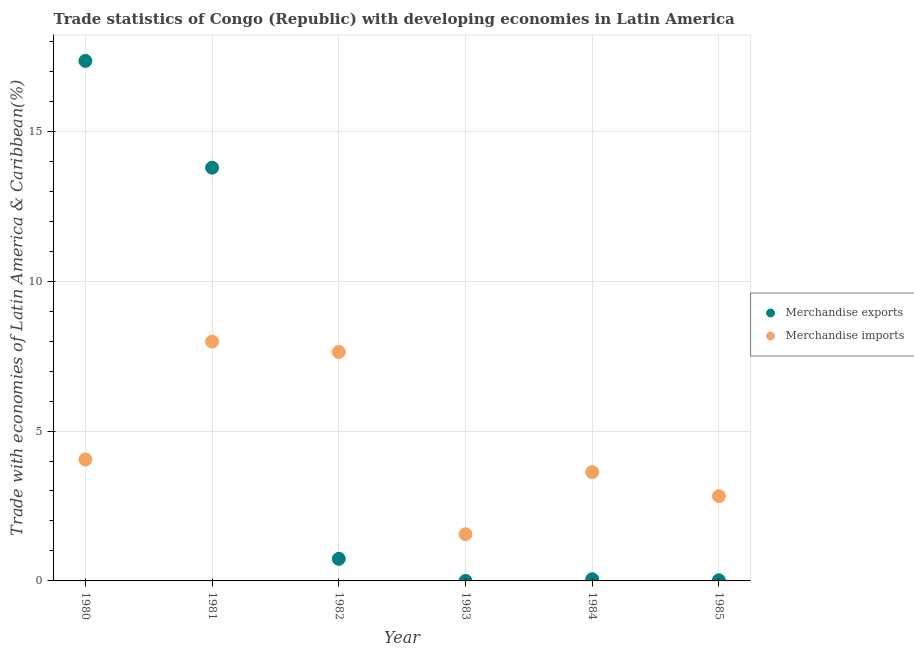What is the merchandise imports in 1980?
Provide a succinct answer. 4.05. Across all years, what is the maximum merchandise imports?
Your response must be concise. 7.98. Across all years, what is the minimum merchandise exports?
Give a very brief answer. 0. In which year was the merchandise imports maximum?
Keep it short and to the point. 1981. What is the total merchandise exports in the graph?
Offer a very short reply. 31.95. What is the difference between the merchandise imports in 1982 and that in 1984?
Provide a succinct answer. 4.01. What is the difference between the merchandise exports in 1981 and the merchandise imports in 1980?
Provide a short and direct response. 9.73. What is the average merchandise imports per year?
Make the answer very short. 4.61. In the year 1983, what is the difference between the merchandise imports and merchandise exports?
Provide a succinct answer. 1.56. In how many years, is the merchandise imports greater than 4 %?
Keep it short and to the point. 3. What is the ratio of the merchandise imports in 1981 to that in 1984?
Provide a short and direct response. 2.2. Is the merchandise exports in 1982 less than that in 1984?
Provide a succinct answer. No. Is the difference between the merchandise imports in 1982 and 1983 greater than the difference between the merchandise exports in 1982 and 1983?
Provide a short and direct response. Yes. What is the difference between the highest and the second highest merchandise exports?
Your answer should be compact. 3.56. What is the difference between the highest and the lowest merchandise imports?
Keep it short and to the point. 6.43. In how many years, is the merchandise imports greater than the average merchandise imports taken over all years?
Ensure brevity in your answer.  2. Is the sum of the merchandise imports in 1983 and 1985 greater than the maximum merchandise exports across all years?
Your answer should be compact. No. Does the merchandise exports monotonically increase over the years?
Provide a succinct answer. No. Is the merchandise imports strictly greater than the merchandise exports over the years?
Ensure brevity in your answer.  No. How many years are there in the graph?
Provide a short and direct response. 6. Does the graph contain any zero values?
Your response must be concise. No. Does the graph contain grids?
Give a very brief answer. Yes. How are the legend labels stacked?
Your answer should be very brief. Vertical. What is the title of the graph?
Your response must be concise. Trade statistics of Congo (Republic) with developing economies in Latin America. Does "Registered firms" appear as one of the legend labels in the graph?
Make the answer very short. No. What is the label or title of the X-axis?
Make the answer very short. Year. What is the label or title of the Y-axis?
Make the answer very short. Trade with economies of Latin America & Caribbean(%). What is the Trade with economies of Latin America & Caribbean(%) of Merchandise exports in 1980?
Provide a succinct answer. 17.35. What is the Trade with economies of Latin America & Caribbean(%) in Merchandise imports in 1980?
Your answer should be very brief. 4.05. What is the Trade with economies of Latin America & Caribbean(%) in Merchandise exports in 1981?
Your response must be concise. 13.78. What is the Trade with economies of Latin America & Caribbean(%) of Merchandise imports in 1981?
Offer a terse response. 7.98. What is the Trade with economies of Latin America & Caribbean(%) of Merchandise exports in 1982?
Ensure brevity in your answer.  0.74. What is the Trade with economies of Latin America & Caribbean(%) in Merchandise imports in 1982?
Keep it short and to the point. 7.64. What is the Trade with economies of Latin America & Caribbean(%) of Merchandise exports in 1983?
Your answer should be very brief. 0. What is the Trade with economies of Latin America & Caribbean(%) of Merchandise imports in 1983?
Offer a terse response. 1.56. What is the Trade with economies of Latin America & Caribbean(%) of Merchandise exports in 1984?
Ensure brevity in your answer.  0.06. What is the Trade with economies of Latin America & Caribbean(%) in Merchandise imports in 1984?
Keep it short and to the point. 3.63. What is the Trade with economies of Latin America & Caribbean(%) of Merchandise exports in 1985?
Your answer should be compact. 0.02. What is the Trade with economies of Latin America & Caribbean(%) in Merchandise imports in 1985?
Your answer should be compact. 2.83. Across all years, what is the maximum Trade with economies of Latin America & Caribbean(%) of Merchandise exports?
Ensure brevity in your answer.  17.35. Across all years, what is the maximum Trade with economies of Latin America & Caribbean(%) in Merchandise imports?
Offer a very short reply. 7.98. Across all years, what is the minimum Trade with economies of Latin America & Caribbean(%) in Merchandise exports?
Your response must be concise. 0. Across all years, what is the minimum Trade with economies of Latin America & Caribbean(%) of Merchandise imports?
Provide a short and direct response. 1.56. What is the total Trade with economies of Latin America & Caribbean(%) of Merchandise exports in the graph?
Your response must be concise. 31.95. What is the total Trade with economies of Latin America & Caribbean(%) in Merchandise imports in the graph?
Give a very brief answer. 27.69. What is the difference between the Trade with economies of Latin America & Caribbean(%) of Merchandise exports in 1980 and that in 1981?
Offer a very short reply. 3.56. What is the difference between the Trade with economies of Latin America & Caribbean(%) in Merchandise imports in 1980 and that in 1981?
Offer a very short reply. -3.93. What is the difference between the Trade with economies of Latin America & Caribbean(%) in Merchandise exports in 1980 and that in 1982?
Offer a terse response. 16.61. What is the difference between the Trade with economies of Latin America & Caribbean(%) in Merchandise imports in 1980 and that in 1982?
Make the answer very short. -3.58. What is the difference between the Trade with economies of Latin America & Caribbean(%) of Merchandise exports in 1980 and that in 1983?
Provide a short and direct response. 17.35. What is the difference between the Trade with economies of Latin America & Caribbean(%) of Merchandise imports in 1980 and that in 1983?
Your answer should be compact. 2.49. What is the difference between the Trade with economies of Latin America & Caribbean(%) in Merchandise exports in 1980 and that in 1984?
Ensure brevity in your answer.  17.29. What is the difference between the Trade with economies of Latin America & Caribbean(%) of Merchandise imports in 1980 and that in 1984?
Your answer should be compact. 0.42. What is the difference between the Trade with economies of Latin America & Caribbean(%) in Merchandise exports in 1980 and that in 1985?
Offer a terse response. 17.33. What is the difference between the Trade with economies of Latin America & Caribbean(%) in Merchandise imports in 1980 and that in 1985?
Provide a short and direct response. 1.23. What is the difference between the Trade with economies of Latin America & Caribbean(%) of Merchandise exports in 1981 and that in 1982?
Keep it short and to the point. 13.05. What is the difference between the Trade with economies of Latin America & Caribbean(%) of Merchandise imports in 1981 and that in 1982?
Your response must be concise. 0.35. What is the difference between the Trade with economies of Latin America & Caribbean(%) in Merchandise exports in 1981 and that in 1983?
Keep it short and to the point. 13.78. What is the difference between the Trade with economies of Latin America & Caribbean(%) in Merchandise imports in 1981 and that in 1983?
Give a very brief answer. 6.43. What is the difference between the Trade with economies of Latin America & Caribbean(%) in Merchandise exports in 1981 and that in 1984?
Your response must be concise. 13.73. What is the difference between the Trade with economies of Latin America & Caribbean(%) in Merchandise imports in 1981 and that in 1984?
Keep it short and to the point. 4.36. What is the difference between the Trade with economies of Latin America & Caribbean(%) of Merchandise exports in 1981 and that in 1985?
Your answer should be compact. 13.76. What is the difference between the Trade with economies of Latin America & Caribbean(%) in Merchandise imports in 1981 and that in 1985?
Provide a short and direct response. 5.16. What is the difference between the Trade with economies of Latin America & Caribbean(%) in Merchandise exports in 1982 and that in 1983?
Offer a very short reply. 0.74. What is the difference between the Trade with economies of Latin America & Caribbean(%) in Merchandise imports in 1982 and that in 1983?
Offer a terse response. 6.08. What is the difference between the Trade with economies of Latin America & Caribbean(%) of Merchandise exports in 1982 and that in 1984?
Your answer should be compact. 0.68. What is the difference between the Trade with economies of Latin America & Caribbean(%) of Merchandise imports in 1982 and that in 1984?
Offer a terse response. 4.01. What is the difference between the Trade with economies of Latin America & Caribbean(%) of Merchandise exports in 1982 and that in 1985?
Offer a very short reply. 0.72. What is the difference between the Trade with economies of Latin America & Caribbean(%) of Merchandise imports in 1982 and that in 1985?
Offer a terse response. 4.81. What is the difference between the Trade with economies of Latin America & Caribbean(%) in Merchandise exports in 1983 and that in 1984?
Ensure brevity in your answer.  -0.06. What is the difference between the Trade with economies of Latin America & Caribbean(%) of Merchandise imports in 1983 and that in 1984?
Ensure brevity in your answer.  -2.07. What is the difference between the Trade with economies of Latin America & Caribbean(%) of Merchandise exports in 1983 and that in 1985?
Make the answer very short. -0.02. What is the difference between the Trade with economies of Latin America & Caribbean(%) of Merchandise imports in 1983 and that in 1985?
Provide a succinct answer. -1.27. What is the difference between the Trade with economies of Latin America & Caribbean(%) in Merchandise exports in 1984 and that in 1985?
Your response must be concise. 0.04. What is the difference between the Trade with economies of Latin America & Caribbean(%) of Merchandise imports in 1984 and that in 1985?
Give a very brief answer. 0.8. What is the difference between the Trade with economies of Latin America & Caribbean(%) of Merchandise exports in 1980 and the Trade with economies of Latin America & Caribbean(%) of Merchandise imports in 1981?
Give a very brief answer. 9.36. What is the difference between the Trade with economies of Latin America & Caribbean(%) of Merchandise exports in 1980 and the Trade with economies of Latin America & Caribbean(%) of Merchandise imports in 1982?
Provide a short and direct response. 9.71. What is the difference between the Trade with economies of Latin America & Caribbean(%) in Merchandise exports in 1980 and the Trade with economies of Latin America & Caribbean(%) in Merchandise imports in 1983?
Make the answer very short. 15.79. What is the difference between the Trade with economies of Latin America & Caribbean(%) of Merchandise exports in 1980 and the Trade with economies of Latin America & Caribbean(%) of Merchandise imports in 1984?
Offer a very short reply. 13.72. What is the difference between the Trade with economies of Latin America & Caribbean(%) of Merchandise exports in 1980 and the Trade with economies of Latin America & Caribbean(%) of Merchandise imports in 1985?
Ensure brevity in your answer.  14.52. What is the difference between the Trade with economies of Latin America & Caribbean(%) of Merchandise exports in 1981 and the Trade with economies of Latin America & Caribbean(%) of Merchandise imports in 1982?
Your answer should be very brief. 6.15. What is the difference between the Trade with economies of Latin America & Caribbean(%) of Merchandise exports in 1981 and the Trade with economies of Latin America & Caribbean(%) of Merchandise imports in 1983?
Your answer should be compact. 12.23. What is the difference between the Trade with economies of Latin America & Caribbean(%) of Merchandise exports in 1981 and the Trade with economies of Latin America & Caribbean(%) of Merchandise imports in 1984?
Ensure brevity in your answer.  10.16. What is the difference between the Trade with economies of Latin America & Caribbean(%) of Merchandise exports in 1981 and the Trade with economies of Latin America & Caribbean(%) of Merchandise imports in 1985?
Offer a very short reply. 10.96. What is the difference between the Trade with economies of Latin America & Caribbean(%) in Merchandise exports in 1982 and the Trade with economies of Latin America & Caribbean(%) in Merchandise imports in 1983?
Your response must be concise. -0.82. What is the difference between the Trade with economies of Latin America & Caribbean(%) of Merchandise exports in 1982 and the Trade with economies of Latin America & Caribbean(%) of Merchandise imports in 1984?
Provide a short and direct response. -2.89. What is the difference between the Trade with economies of Latin America & Caribbean(%) in Merchandise exports in 1982 and the Trade with economies of Latin America & Caribbean(%) in Merchandise imports in 1985?
Your answer should be very brief. -2.09. What is the difference between the Trade with economies of Latin America & Caribbean(%) of Merchandise exports in 1983 and the Trade with economies of Latin America & Caribbean(%) of Merchandise imports in 1984?
Your answer should be compact. -3.63. What is the difference between the Trade with economies of Latin America & Caribbean(%) in Merchandise exports in 1983 and the Trade with economies of Latin America & Caribbean(%) in Merchandise imports in 1985?
Your response must be concise. -2.83. What is the difference between the Trade with economies of Latin America & Caribbean(%) in Merchandise exports in 1984 and the Trade with economies of Latin America & Caribbean(%) in Merchandise imports in 1985?
Make the answer very short. -2.77. What is the average Trade with economies of Latin America & Caribbean(%) of Merchandise exports per year?
Offer a very short reply. 5.32. What is the average Trade with economies of Latin America & Caribbean(%) in Merchandise imports per year?
Give a very brief answer. 4.61. In the year 1980, what is the difference between the Trade with economies of Latin America & Caribbean(%) in Merchandise exports and Trade with economies of Latin America & Caribbean(%) in Merchandise imports?
Ensure brevity in your answer.  13.29. In the year 1981, what is the difference between the Trade with economies of Latin America & Caribbean(%) of Merchandise exports and Trade with economies of Latin America & Caribbean(%) of Merchandise imports?
Your answer should be very brief. 5.8. In the year 1982, what is the difference between the Trade with economies of Latin America & Caribbean(%) in Merchandise exports and Trade with economies of Latin America & Caribbean(%) in Merchandise imports?
Provide a short and direct response. -6.9. In the year 1983, what is the difference between the Trade with economies of Latin America & Caribbean(%) in Merchandise exports and Trade with economies of Latin America & Caribbean(%) in Merchandise imports?
Provide a short and direct response. -1.56. In the year 1984, what is the difference between the Trade with economies of Latin America & Caribbean(%) of Merchandise exports and Trade with economies of Latin America & Caribbean(%) of Merchandise imports?
Ensure brevity in your answer.  -3.57. In the year 1985, what is the difference between the Trade with economies of Latin America & Caribbean(%) of Merchandise exports and Trade with economies of Latin America & Caribbean(%) of Merchandise imports?
Your answer should be very brief. -2.81. What is the ratio of the Trade with economies of Latin America & Caribbean(%) in Merchandise exports in 1980 to that in 1981?
Offer a terse response. 1.26. What is the ratio of the Trade with economies of Latin America & Caribbean(%) in Merchandise imports in 1980 to that in 1981?
Your answer should be compact. 0.51. What is the ratio of the Trade with economies of Latin America & Caribbean(%) of Merchandise exports in 1980 to that in 1982?
Provide a succinct answer. 23.52. What is the ratio of the Trade with economies of Latin America & Caribbean(%) of Merchandise imports in 1980 to that in 1982?
Offer a very short reply. 0.53. What is the ratio of the Trade with economies of Latin America & Caribbean(%) in Merchandise exports in 1980 to that in 1983?
Your answer should be very brief. 2.11e+04. What is the ratio of the Trade with economies of Latin America & Caribbean(%) in Merchandise imports in 1980 to that in 1983?
Your answer should be very brief. 2.6. What is the ratio of the Trade with economies of Latin America & Caribbean(%) of Merchandise exports in 1980 to that in 1984?
Your answer should be compact. 305.93. What is the ratio of the Trade with economies of Latin America & Caribbean(%) of Merchandise imports in 1980 to that in 1984?
Give a very brief answer. 1.12. What is the ratio of the Trade with economies of Latin America & Caribbean(%) in Merchandise exports in 1980 to that in 1985?
Your answer should be very brief. 838.82. What is the ratio of the Trade with economies of Latin America & Caribbean(%) in Merchandise imports in 1980 to that in 1985?
Give a very brief answer. 1.43. What is the ratio of the Trade with economies of Latin America & Caribbean(%) in Merchandise exports in 1981 to that in 1982?
Provide a succinct answer. 18.69. What is the ratio of the Trade with economies of Latin America & Caribbean(%) of Merchandise imports in 1981 to that in 1982?
Your answer should be very brief. 1.05. What is the ratio of the Trade with economies of Latin America & Caribbean(%) of Merchandise exports in 1981 to that in 1983?
Provide a short and direct response. 1.68e+04. What is the ratio of the Trade with economies of Latin America & Caribbean(%) in Merchandise imports in 1981 to that in 1983?
Offer a very short reply. 5.13. What is the ratio of the Trade with economies of Latin America & Caribbean(%) of Merchandise exports in 1981 to that in 1984?
Provide a succinct answer. 243.1. What is the ratio of the Trade with economies of Latin America & Caribbean(%) in Merchandise imports in 1981 to that in 1984?
Your answer should be compact. 2.2. What is the ratio of the Trade with economies of Latin America & Caribbean(%) in Merchandise exports in 1981 to that in 1985?
Offer a very short reply. 666.55. What is the ratio of the Trade with economies of Latin America & Caribbean(%) in Merchandise imports in 1981 to that in 1985?
Your answer should be compact. 2.82. What is the ratio of the Trade with economies of Latin America & Caribbean(%) in Merchandise exports in 1982 to that in 1983?
Provide a short and direct response. 897.85. What is the ratio of the Trade with economies of Latin America & Caribbean(%) in Merchandise imports in 1982 to that in 1983?
Your answer should be compact. 4.9. What is the ratio of the Trade with economies of Latin America & Caribbean(%) of Merchandise exports in 1982 to that in 1984?
Offer a terse response. 13. What is the ratio of the Trade with economies of Latin America & Caribbean(%) in Merchandise imports in 1982 to that in 1984?
Your response must be concise. 2.11. What is the ratio of the Trade with economies of Latin America & Caribbean(%) in Merchandise exports in 1982 to that in 1985?
Provide a succinct answer. 35.66. What is the ratio of the Trade with economies of Latin America & Caribbean(%) of Merchandise imports in 1982 to that in 1985?
Provide a short and direct response. 2.7. What is the ratio of the Trade with economies of Latin America & Caribbean(%) of Merchandise exports in 1983 to that in 1984?
Make the answer very short. 0.01. What is the ratio of the Trade with economies of Latin America & Caribbean(%) of Merchandise imports in 1983 to that in 1984?
Give a very brief answer. 0.43. What is the ratio of the Trade with economies of Latin America & Caribbean(%) in Merchandise exports in 1983 to that in 1985?
Make the answer very short. 0.04. What is the ratio of the Trade with economies of Latin America & Caribbean(%) in Merchandise imports in 1983 to that in 1985?
Make the answer very short. 0.55. What is the ratio of the Trade with economies of Latin America & Caribbean(%) in Merchandise exports in 1984 to that in 1985?
Your response must be concise. 2.74. What is the ratio of the Trade with economies of Latin America & Caribbean(%) of Merchandise imports in 1984 to that in 1985?
Keep it short and to the point. 1.28. What is the difference between the highest and the second highest Trade with economies of Latin America & Caribbean(%) of Merchandise exports?
Make the answer very short. 3.56. What is the difference between the highest and the second highest Trade with economies of Latin America & Caribbean(%) of Merchandise imports?
Give a very brief answer. 0.35. What is the difference between the highest and the lowest Trade with economies of Latin America & Caribbean(%) of Merchandise exports?
Your response must be concise. 17.35. What is the difference between the highest and the lowest Trade with economies of Latin America & Caribbean(%) in Merchandise imports?
Ensure brevity in your answer.  6.43. 